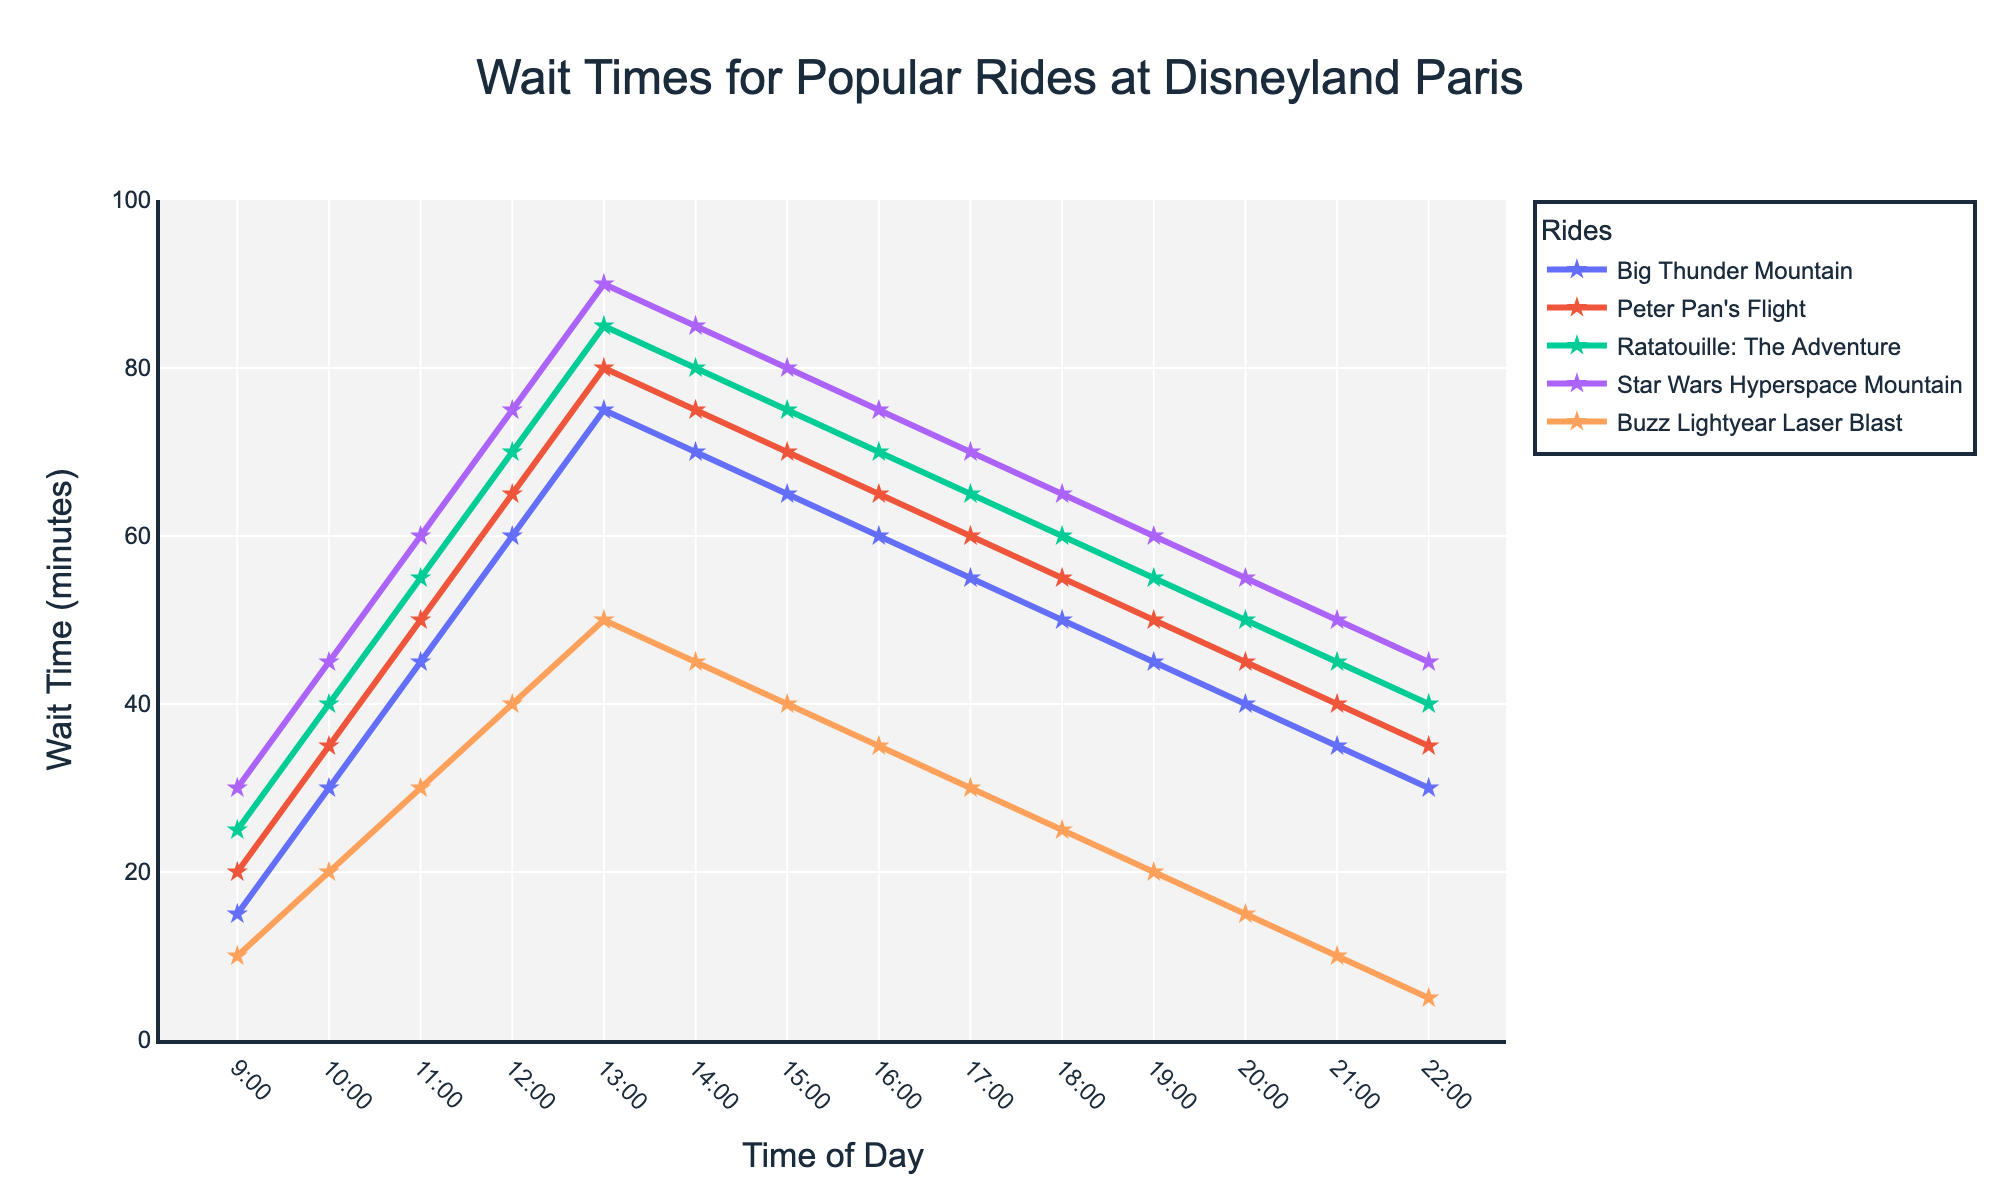What's the average wait time for Peter Pan's Flight at 10:00, 14:00, and 20:00? First, find the wait times for Peter Pan's Flight at 10:00, 14:00, and 20:00, which are 35, 75, and 45 minutes respectively. Next, sum these values (35 + 75 + 45 = 155) and then divide by the number of data points, which is 3. So, 155/3 = 51.67 minutes.
Answer: 51.67 minutes Which ride has the longest wait time at 13:00? Look at the wait times at 13:00 for each ride: Big Thunder Mountain (75 min), Peter Pan's Flight (80 min), Ratatouille: The Adventure (85 min), Star Wars Hyperspace Mountain (90 min), and Buzz Lightyear Laser Blast (50 min). The longest wait time is 90 minutes for Star Wars Hyperspace Mountain.
Answer: Star Wars Hyperspace Mountain At what time does Buzz Lightyear Laser Blast have the shortest wait time? Examine the line for Buzz Lightyear Laser Blast and identify the point with the lowest wait time. The shortest wait time, 5 minutes, occurs at 22:00.
Answer: 22:00 How much does the wait time for Ratatouille: The Adventure increase from 9:00 to 12:00? Find the wait times for Ratatouille: The Adventure at 9:00 (25 min) and at 12:00 (70 min). Subtract the earlier wait time from the later wait time (70 - 25 = 45 minutes).
Answer: 45 minutes Which ride's wait time decreases the most from 13:00 to 22:00? Calculate the difference in wait times at 13:00 and 22:00 for each ride: Big Thunder Mountain (75 - 30 = 45 min), Peter Pan's Flight (80 - 35 = 45 min), Ratatouille: The Adventure (85 - 40 = 45 min), Star Wars Hyperspace Mountain (90 - 45 = 45 min), Buzz Lightyear Laser Blast (50 - 5 = 45 min). Each ride's wait time decreases the same amount, 45 minutes.
Answer: All rides (each by 45 minutes) If you want to experience the shortest wait times for all rides, what time should you go? Examine the graph and identify the time slots where all rides have the shortest wait times. This occurs at 22:00 with the respective wait times: Big Thunder Mountain (30 min), Peter Pan's Flight (35 min), Ratatouille: The Adventure (40 min), Star Wars Hyperspace Mountain (45 min), and Buzz Lightyear Laser Blast (5 min).
Answer: 22:00 How do the wait times for Big Thunder Mountain compare between 10:00 and 16:00? Find the wait times for Big Thunder Mountain at 10:00 (30 min) and at 16:00 (60 min). The wait time is 30 minutes higher at 16:00 compared to 10:00.
Answer: 30 minutes higher What is the average wait time across all rides at 11:00? Find the wait times for all rides at 11:00: Big Thunder Mountain (45 min), Peter Pan's Flight (50 min), Ratatouille: The Adventure (55 min), Star Wars Hyperspace Mountain (60 min), Buzz Lightyear Laser Blast (30 min). Sum these values (45 + 50 + 55 + 60 + 30 = 240) and divide by the number of rides, which is 5. So, 240/5 = 48 minutes.
Answer: 48 minutes 